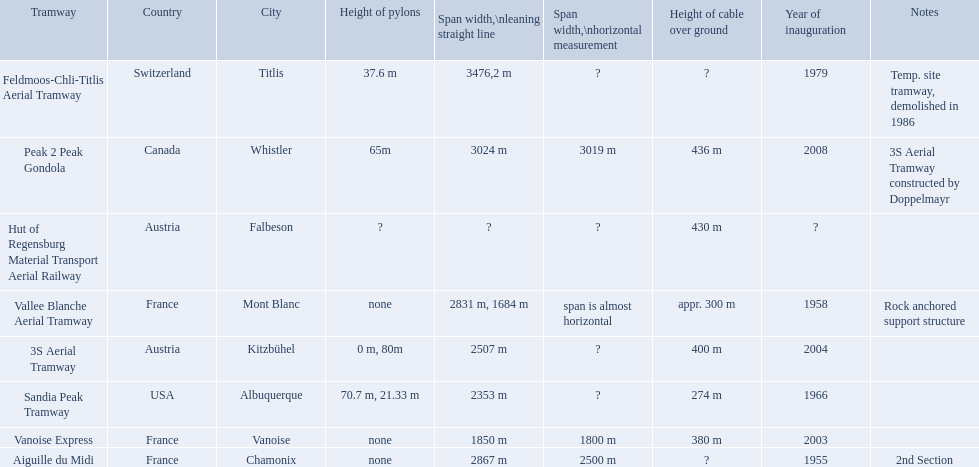What are all of the tramways? Peak 2 Peak Gondola, Hut of Regensburg Material Transport Aerial Railway, Vanoise Express, Aiguille du Midi, Vallee Blanche Aerial Tramway, 3S Aerial Tramway, Sandia Peak Tramway, Feldmoos-Chli-Titlis Aerial Tramway. When were they inaugurated? 2008, ?, 2003, 1955, 1958, 2004, 1966, 1979. Now, between 3s aerial tramway and aiguille du midi, which was inaugurated first? Aiguille du Midi. 